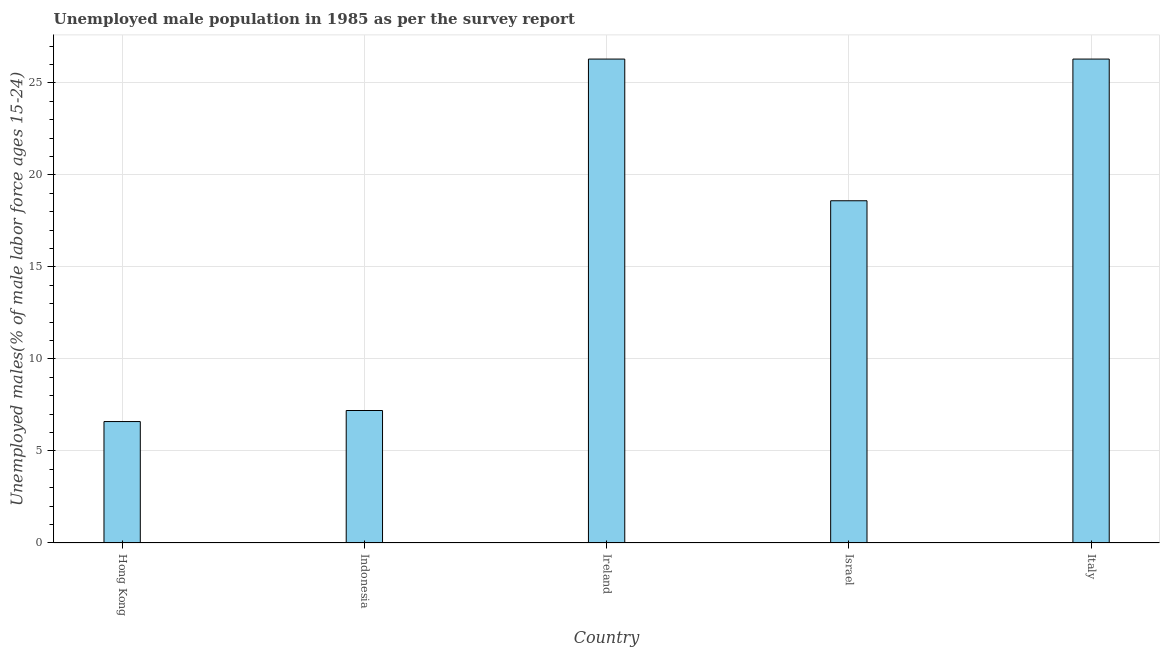What is the title of the graph?
Keep it short and to the point. Unemployed male population in 1985 as per the survey report. What is the label or title of the X-axis?
Provide a short and direct response. Country. What is the label or title of the Y-axis?
Ensure brevity in your answer.  Unemployed males(% of male labor force ages 15-24). What is the unemployed male youth in Hong Kong?
Offer a very short reply. 6.6. Across all countries, what is the maximum unemployed male youth?
Give a very brief answer. 26.3. Across all countries, what is the minimum unemployed male youth?
Provide a short and direct response. 6.6. In which country was the unemployed male youth maximum?
Your response must be concise. Ireland. In which country was the unemployed male youth minimum?
Offer a very short reply. Hong Kong. What is the sum of the unemployed male youth?
Your response must be concise. 85. What is the difference between the unemployed male youth in Hong Kong and Ireland?
Your answer should be compact. -19.7. What is the median unemployed male youth?
Offer a terse response. 18.6. In how many countries, is the unemployed male youth greater than 15 %?
Offer a terse response. 3. What is the ratio of the unemployed male youth in Ireland to that in Israel?
Your answer should be very brief. 1.41. What is the difference between the highest and the lowest unemployed male youth?
Offer a terse response. 19.7. Are all the bars in the graph horizontal?
Provide a succinct answer. No. How many countries are there in the graph?
Give a very brief answer. 5. What is the difference between two consecutive major ticks on the Y-axis?
Your answer should be very brief. 5. What is the Unemployed males(% of male labor force ages 15-24) of Hong Kong?
Your answer should be compact. 6.6. What is the Unemployed males(% of male labor force ages 15-24) in Indonesia?
Offer a very short reply. 7.2. What is the Unemployed males(% of male labor force ages 15-24) in Ireland?
Your answer should be very brief. 26.3. What is the Unemployed males(% of male labor force ages 15-24) of Israel?
Provide a succinct answer. 18.6. What is the Unemployed males(% of male labor force ages 15-24) in Italy?
Give a very brief answer. 26.3. What is the difference between the Unemployed males(% of male labor force ages 15-24) in Hong Kong and Ireland?
Provide a succinct answer. -19.7. What is the difference between the Unemployed males(% of male labor force ages 15-24) in Hong Kong and Israel?
Ensure brevity in your answer.  -12. What is the difference between the Unemployed males(% of male labor force ages 15-24) in Hong Kong and Italy?
Keep it short and to the point. -19.7. What is the difference between the Unemployed males(% of male labor force ages 15-24) in Indonesia and Ireland?
Ensure brevity in your answer.  -19.1. What is the difference between the Unemployed males(% of male labor force ages 15-24) in Indonesia and Italy?
Keep it short and to the point. -19.1. What is the difference between the Unemployed males(% of male labor force ages 15-24) in Israel and Italy?
Offer a very short reply. -7.7. What is the ratio of the Unemployed males(% of male labor force ages 15-24) in Hong Kong to that in Indonesia?
Keep it short and to the point. 0.92. What is the ratio of the Unemployed males(% of male labor force ages 15-24) in Hong Kong to that in Ireland?
Keep it short and to the point. 0.25. What is the ratio of the Unemployed males(% of male labor force ages 15-24) in Hong Kong to that in Israel?
Provide a short and direct response. 0.35. What is the ratio of the Unemployed males(% of male labor force ages 15-24) in Hong Kong to that in Italy?
Provide a short and direct response. 0.25. What is the ratio of the Unemployed males(% of male labor force ages 15-24) in Indonesia to that in Ireland?
Your answer should be compact. 0.27. What is the ratio of the Unemployed males(% of male labor force ages 15-24) in Indonesia to that in Israel?
Offer a terse response. 0.39. What is the ratio of the Unemployed males(% of male labor force ages 15-24) in Indonesia to that in Italy?
Your answer should be compact. 0.27. What is the ratio of the Unemployed males(% of male labor force ages 15-24) in Ireland to that in Israel?
Provide a short and direct response. 1.41. What is the ratio of the Unemployed males(% of male labor force ages 15-24) in Israel to that in Italy?
Your answer should be very brief. 0.71. 